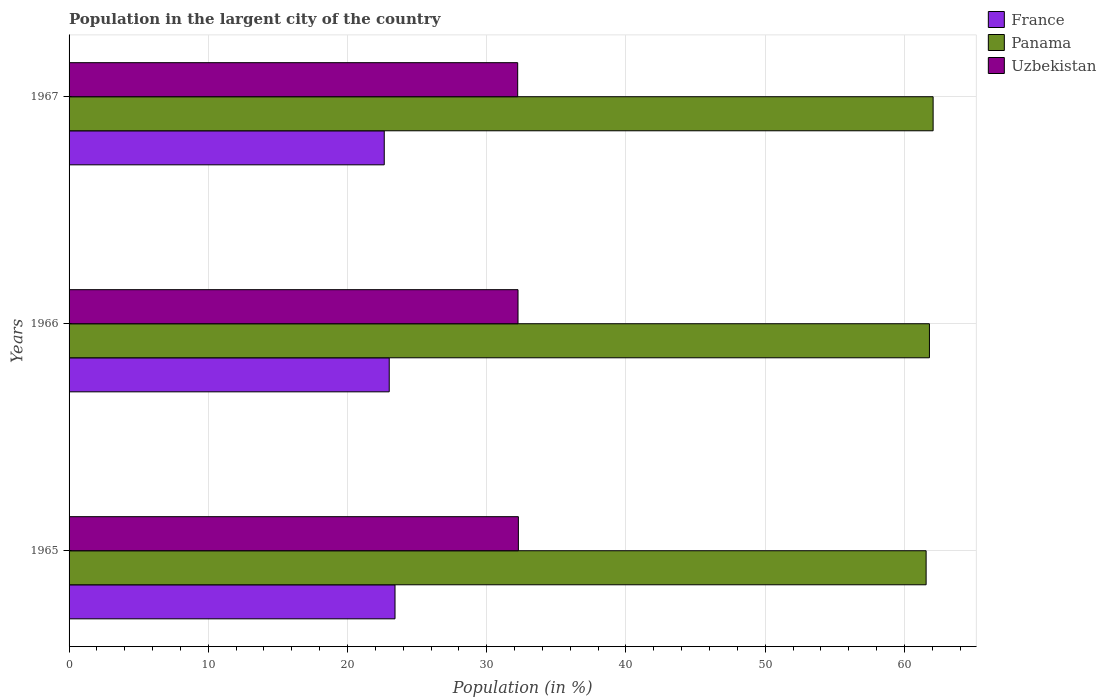How many different coloured bars are there?
Give a very brief answer. 3. How many groups of bars are there?
Keep it short and to the point. 3. Are the number of bars per tick equal to the number of legend labels?
Keep it short and to the point. Yes. Are the number of bars on each tick of the Y-axis equal?
Offer a terse response. Yes. How many bars are there on the 3rd tick from the bottom?
Your answer should be very brief. 3. What is the label of the 1st group of bars from the top?
Offer a terse response. 1967. In how many cases, is the number of bars for a given year not equal to the number of legend labels?
Give a very brief answer. 0. What is the percentage of population in the largent city in France in 1967?
Provide a succinct answer. 22.64. Across all years, what is the maximum percentage of population in the largent city in France?
Provide a succinct answer. 23.41. Across all years, what is the minimum percentage of population in the largent city in Uzbekistan?
Offer a very short reply. 32.22. In which year was the percentage of population in the largent city in Uzbekistan maximum?
Make the answer very short. 1965. In which year was the percentage of population in the largent city in Uzbekistan minimum?
Offer a very short reply. 1967. What is the total percentage of population in the largent city in Panama in the graph?
Your answer should be very brief. 185.42. What is the difference between the percentage of population in the largent city in Panama in 1965 and that in 1967?
Make the answer very short. -0.5. What is the difference between the percentage of population in the largent city in Uzbekistan in 1967 and the percentage of population in the largent city in Panama in 1965?
Your answer should be very brief. -29.34. What is the average percentage of population in the largent city in France per year?
Your answer should be very brief. 23.02. In the year 1967, what is the difference between the percentage of population in the largent city in France and percentage of population in the largent city in Uzbekistan?
Ensure brevity in your answer.  -9.59. In how many years, is the percentage of population in the largent city in Panama greater than 44 %?
Your answer should be very brief. 3. What is the ratio of the percentage of population in the largent city in Uzbekistan in 1965 to that in 1967?
Your answer should be very brief. 1. Is the difference between the percentage of population in the largent city in France in 1966 and 1967 greater than the difference between the percentage of population in the largent city in Uzbekistan in 1966 and 1967?
Keep it short and to the point. Yes. What is the difference between the highest and the second highest percentage of population in the largent city in Uzbekistan?
Your response must be concise. 0.03. What is the difference between the highest and the lowest percentage of population in the largent city in France?
Give a very brief answer. 0.77. What does the 2nd bar from the bottom in 1966 represents?
Give a very brief answer. Panama. Are all the bars in the graph horizontal?
Offer a very short reply. Yes. Are the values on the major ticks of X-axis written in scientific E-notation?
Your answer should be compact. No. How many legend labels are there?
Provide a short and direct response. 3. How are the legend labels stacked?
Provide a short and direct response. Vertical. What is the title of the graph?
Your response must be concise. Population in the largent city of the country. What is the label or title of the X-axis?
Ensure brevity in your answer.  Population (in %). What is the label or title of the Y-axis?
Ensure brevity in your answer.  Years. What is the Population (in %) of France in 1965?
Provide a succinct answer. 23.41. What is the Population (in %) in Panama in 1965?
Ensure brevity in your answer.  61.56. What is the Population (in %) in Uzbekistan in 1965?
Your response must be concise. 32.27. What is the Population (in %) in France in 1966?
Provide a short and direct response. 23. What is the Population (in %) in Panama in 1966?
Provide a short and direct response. 61.8. What is the Population (in %) of Uzbekistan in 1966?
Keep it short and to the point. 32.25. What is the Population (in %) in France in 1967?
Offer a very short reply. 22.64. What is the Population (in %) of Panama in 1967?
Your response must be concise. 62.06. What is the Population (in %) of Uzbekistan in 1967?
Your answer should be very brief. 32.22. Across all years, what is the maximum Population (in %) of France?
Your response must be concise. 23.41. Across all years, what is the maximum Population (in %) of Panama?
Keep it short and to the point. 62.06. Across all years, what is the maximum Population (in %) of Uzbekistan?
Ensure brevity in your answer.  32.27. Across all years, what is the minimum Population (in %) of France?
Give a very brief answer. 22.64. Across all years, what is the minimum Population (in %) of Panama?
Give a very brief answer. 61.56. Across all years, what is the minimum Population (in %) of Uzbekistan?
Make the answer very short. 32.22. What is the total Population (in %) of France in the graph?
Offer a terse response. 69.05. What is the total Population (in %) in Panama in the graph?
Your response must be concise. 185.42. What is the total Population (in %) of Uzbekistan in the graph?
Make the answer very short. 96.74. What is the difference between the Population (in %) in France in 1965 and that in 1966?
Your answer should be compact. 0.42. What is the difference between the Population (in %) of Panama in 1965 and that in 1966?
Keep it short and to the point. -0.24. What is the difference between the Population (in %) of Uzbekistan in 1965 and that in 1966?
Keep it short and to the point. 0.03. What is the difference between the Population (in %) in France in 1965 and that in 1967?
Keep it short and to the point. 0.77. What is the difference between the Population (in %) in Panama in 1965 and that in 1967?
Ensure brevity in your answer.  -0.5. What is the difference between the Population (in %) in Uzbekistan in 1965 and that in 1967?
Keep it short and to the point. 0.05. What is the difference between the Population (in %) of France in 1966 and that in 1967?
Make the answer very short. 0.36. What is the difference between the Population (in %) of Panama in 1966 and that in 1967?
Give a very brief answer. -0.26. What is the difference between the Population (in %) of Uzbekistan in 1966 and that in 1967?
Provide a short and direct response. 0.02. What is the difference between the Population (in %) of France in 1965 and the Population (in %) of Panama in 1966?
Ensure brevity in your answer.  -38.39. What is the difference between the Population (in %) in France in 1965 and the Population (in %) in Uzbekistan in 1966?
Keep it short and to the point. -8.83. What is the difference between the Population (in %) of Panama in 1965 and the Population (in %) of Uzbekistan in 1966?
Your answer should be very brief. 29.31. What is the difference between the Population (in %) of France in 1965 and the Population (in %) of Panama in 1967?
Your response must be concise. -38.65. What is the difference between the Population (in %) in France in 1965 and the Population (in %) in Uzbekistan in 1967?
Your answer should be compact. -8.81. What is the difference between the Population (in %) in Panama in 1965 and the Population (in %) in Uzbekistan in 1967?
Your answer should be very brief. 29.34. What is the difference between the Population (in %) in France in 1966 and the Population (in %) in Panama in 1967?
Provide a short and direct response. -39.07. What is the difference between the Population (in %) in France in 1966 and the Population (in %) in Uzbekistan in 1967?
Make the answer very short. -9.23. What is the difference between the Population (in %) in Panama in 1966 and the Population (in %) in Uzbekistan in 1967?
Your response must be concise. 29.58. What is the average Population (in %) in France per year?
Your response must be concise. 23.02. What is the average Population (in %) of Panama per year?
Your answer should be compact. 61.81. What is the average Population (in %) of Uzbekistan per year?
Offer a very short reply. 32.25. In the year 1965, what is the difference between the Population (in %) of France and Population (in %) of Panama?
Provide a short and direct response. -38.15. In the year 1965, what is the difference between the Population (in %) of France and Population (in %) of Uzbekistan?
Offer a terse response. -8.86. In the year 1965, what is the difference between the Population (in %) of Panama and Population (in %) of Uzbekistan?
Provide a succinct answer. 29.29. In the year 1966, what is the difference between the Population (in %) of France and Population (in %) of Panama?
Your answer should be compact. -38.8. In the year 1966, what is the difference between the Population (in %) of France and Population (in %) of Uzbekistan?
Your response must be concise. -9.25. In the year 1966, what is the difference between the Population (in %) in Panama and Population (in %) in Uzbekistan?
Ensure brevity in your answer.  29.55. In the year 1967, what is the difference between the Population (in %) of France and Population (in %) of Panama?
Give a very brief answer. -39.42. In the year 1967, what is the difference between the Population (in %) of France and Population (in %) of Uzbekistan?
Your answer should be very brief. -9.59. In the year 1967, what is the difference between the Population (in %) of Panama and Population (in %) of Uzbekistan?
Offer a very short reply. 29.84. What is the ratio of the Population (in %) in France in 1965 to that in 1966?
Offer a very short reply. 1.02. What is the ratio of the Population (in %) in Panama in 1965 to that in 1966?
Keep it short and to the point. 1. What is the ratio of the Population (in %) in Uzbekistan in 1965 to that in 1966?
Ensure brevity in your answer.  1. What is the ratio of the Population (in %) of France in 1965 to that in 1967?
Your answer should be very brief. 1.03. What is the ratio of the Population (in %) in France in 1966 to that in 1967?
Keep it short and to the point. 1.02. What is the ratio of the Population (in %) of Panama in 1966 to that in 1967?
Provide a short and direct response. 1. What is the ratio of the Population (in %) in Uzbekistan in 1966 to that in 1967?
Provide a succinct answer. 1. What is the difference between the highest and the second highest Population (in %) in France?
Your answer should be very brief. 0.42. What is the difference between the highest and the second highest Population (in %) in Panama?
Your answer should be very brief. 0.26. What is the difference between the highest and the second highest Population (in %) in Uzbekistan?
Your answer should be compact. 0.03. What is the difference between the highest and the lowest Population (in %) of France?
Give a very brief answer. 0.77. What is the difference between the highest and the lowest Population (in %) of Panama?
Give a very brief answer. 0.5. What is the difference between the highest and the lowest Population (in %) of Uzbekistan?
Ensure brevity in your answer.  0.05. 